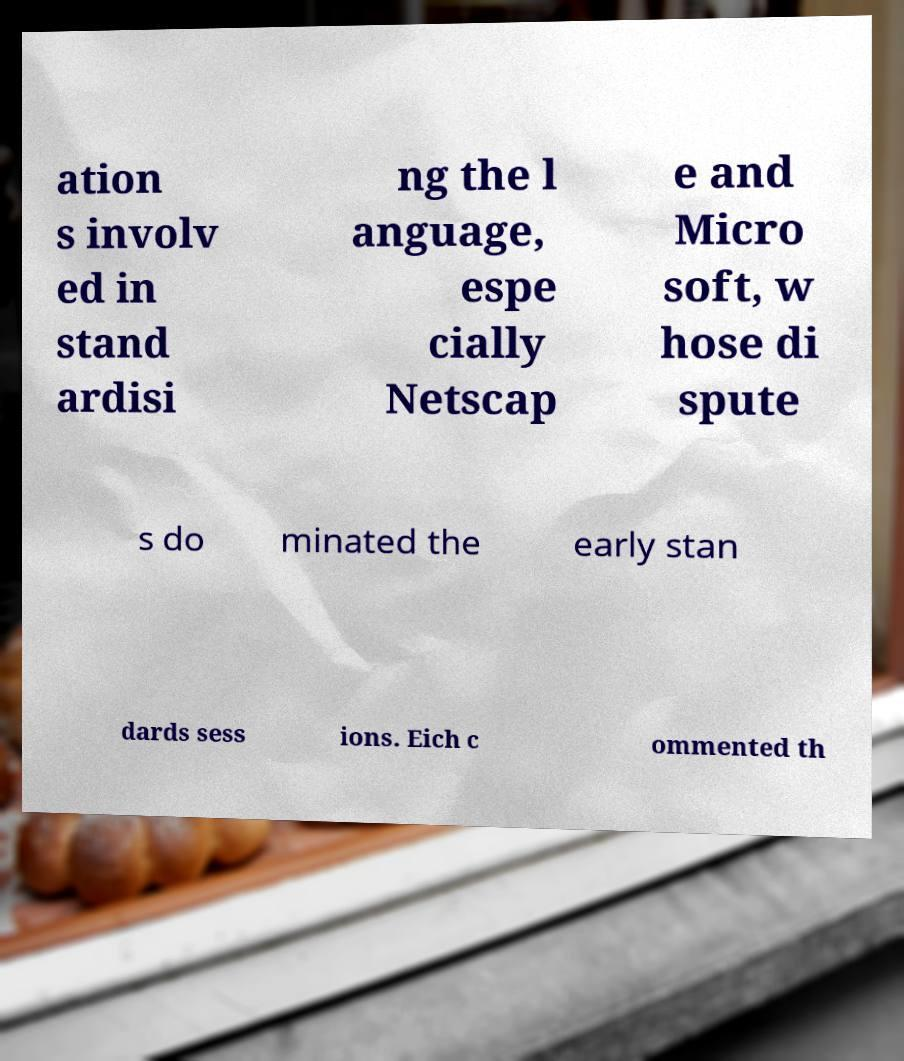Could you extract and type out the text from this image? ation s involv ed in stand ardisi ng the l anguage, espe cially Netscap e and Micro soft, w hose di spute s do minated the early stan dards sess ions. Eich c ommented th 